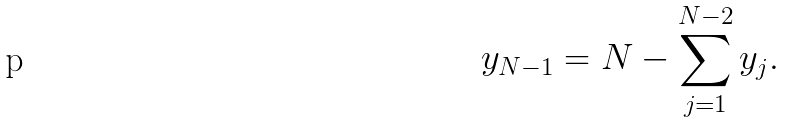Convert formula to latex. <formula><loc_0><loc_0><loc_500><loc_500>y _ { N - 1 } = N - \sum _ { j = 1 } ^ { N - 2 } y _ { j } .</formula> 